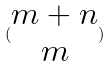<formula> <loc_0><loc_0><loc_500><loc_500>( \begin{matrix} m + n \\ m \end{matrix} )</formula> 